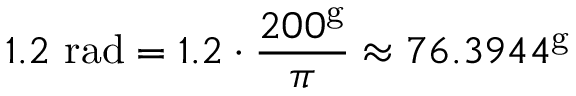<formula> <loc_0><loc_0><loc_500><loc_500>1 . 2 { r a d } = 1 . 2 \cdot { \frac { 2 0 0 ^ { g } } { \pi } } \approx 7 6 . 3 9 4 4 ^ { g }</formula> 